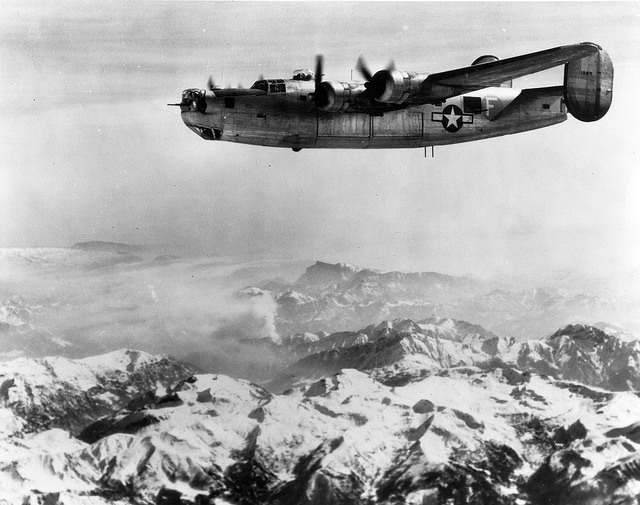Please extract the text content from this image. F 